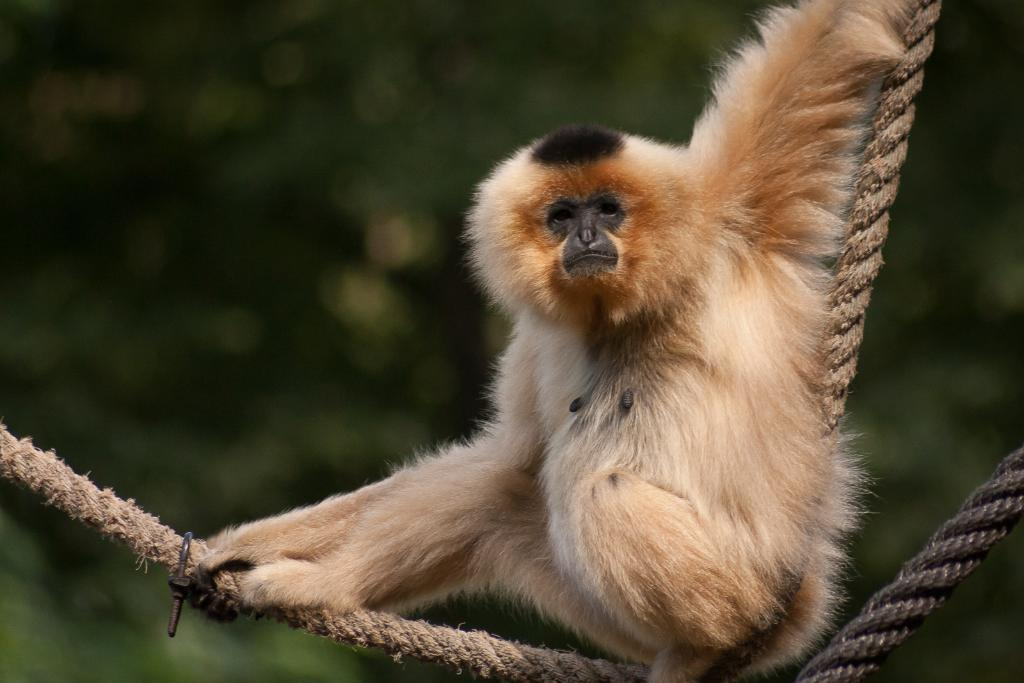What type of animal is in the image? There is a monkey in the image. What color is the monkey? The monkey is pale brown in color. What objects are visible in the image besides the monkey? There are ropes visible in the image. How would you describe the background of the image? The background of the image is blurred. What type of sugar is being used to write letters in the image? There is no sugar or letters present in the image; it features a monkey and ropes with a blurred background. 